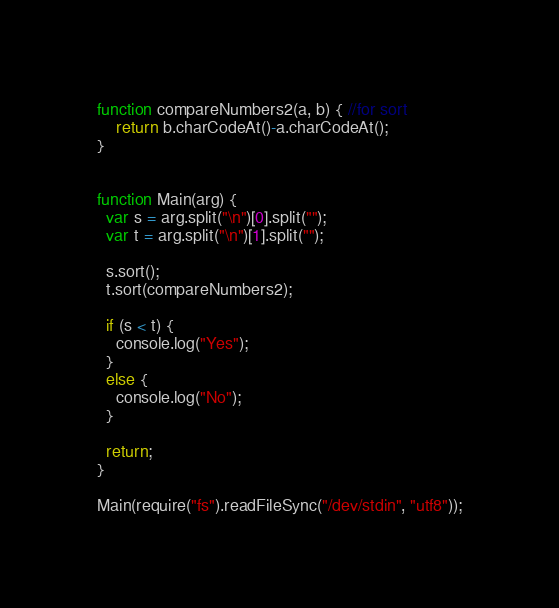Convert code to text. <code><loc_0><loc_0><loc_500><loc_500><_JavaScript_>function compareNumbers2(a, b) { //for sort
    return b.charCodeAt()-a.charCodeAt();
}


function Main(arg) {
  var s = arg.split("\n")[0].split("");
  var t = arg.split("\n")[1].split("");

  s.sort();
  t.sort(compareNumbers2);

  if (s < t) {
    console.log("Yes");
  }
  else {
    console.log("No");
  }

  return;
}

Main(require("fs").readFileSync("/dev/stdin", "utf8"));</code> 